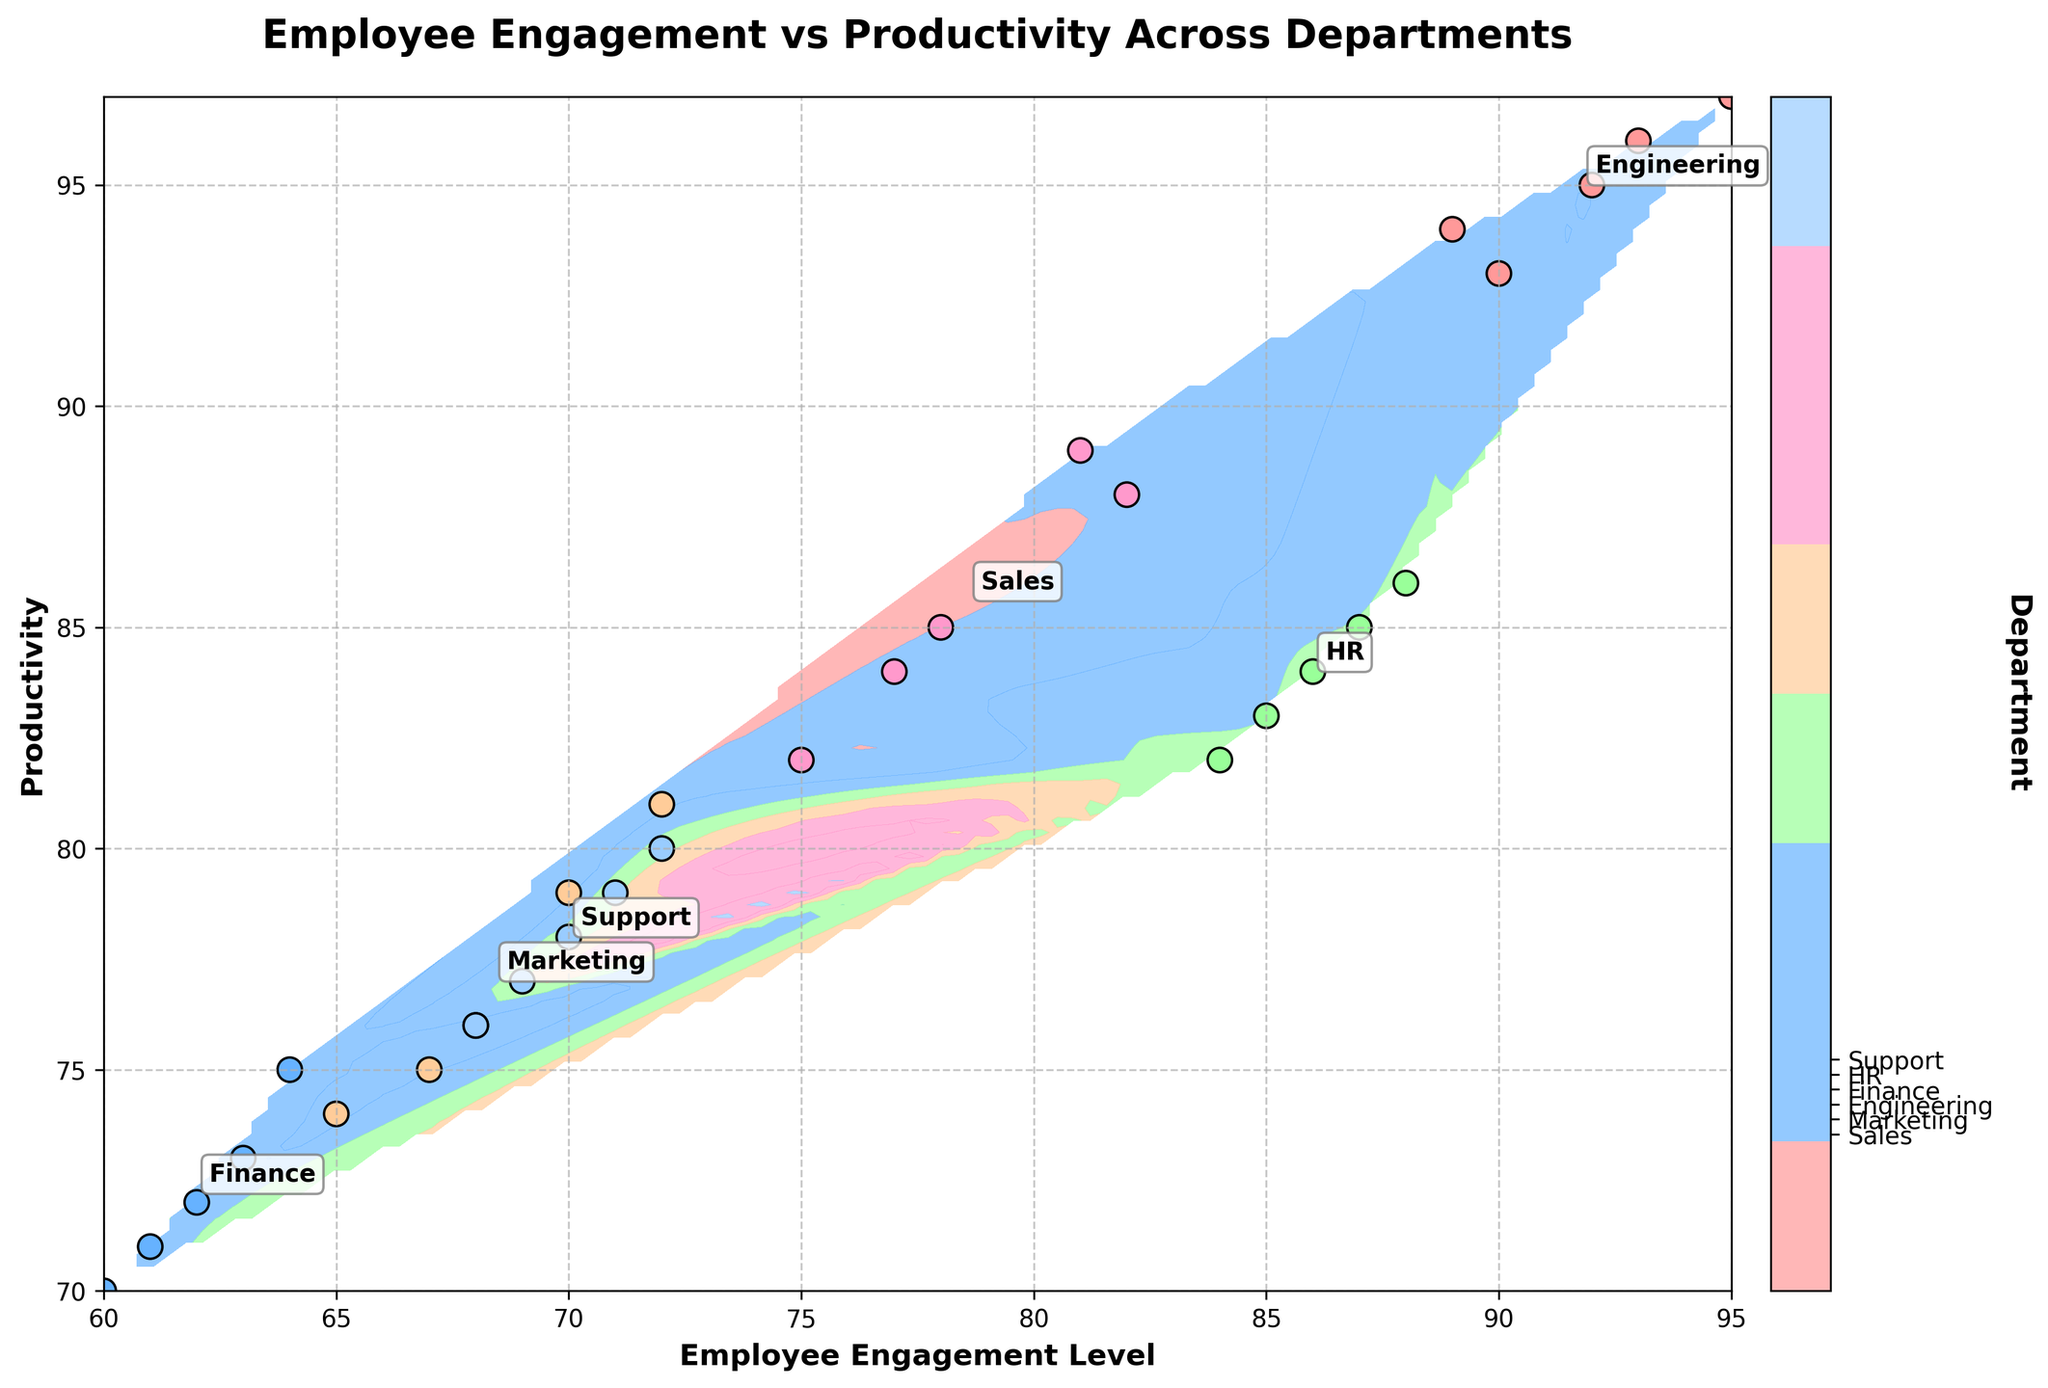What is the title of the plot? The title is usually displayed at the top of the plot. It should summarize the main focus of the data visualization, which in this case is 'Employee Engagement vs Productivity Across Departments'.
Answer: Employee Engagement vs Productivity Across Departments What does the x-axis represent? The x-axis label provides information about what is plotted on the horizontal axis. It indicates 'Employee Engagement Level'.
Answer: Employee Engagement Level Which department has the highest average employee engagement level? By locating the annotations for each department on the plot and comparing their average engagement levels, Engineering has the highest average employee engagement.
Answer: Engineering What is the colormap of the plot used for? The colormap visually distinguishes the different departments based on the color gradient. The color bar on the plot assigns these colors to the respective departments.
Answer: To differentiate departments How many departments are displayed on the plot? Count the distinct department annotations or the ticks on the color bar. There are six departments: Sales, Marketing, Engineering, Finance, HR, and Support.
Answer: Six Which department has the lowest productivity score? By looking at the scatter points and annotations on the y-axis, Finance has the lowest productivity scores.
Answer: Finance What is the average productivity level of the HR department? Locate the HR scatter points and annotations, then calculate the average of the HR productivity values (83, 85, 86, 84, 82): (83+85+86+84+82)/5 = 84.
Answer: 84 How do the productivity levels of Sales and Marketing compare? Compare their average productivity by observing the scatter points and text annotations. Sales has a higher average productivity level than Marketing.
Answer: Sales have higher productivity Which department shows a strong correlation between employee engagement level and productivity? By observing the spread and alignment of the scatter points for each department, Engineering shows a strong correlation with closely aligned points.
Answer: Engineering What feature of the plot helps identify the engagement level at a specific productivity score? The contour lines and grid provide an interpolation of engagement levels across different productivity scores, helping to approximate values.
Answer: Contour lines 